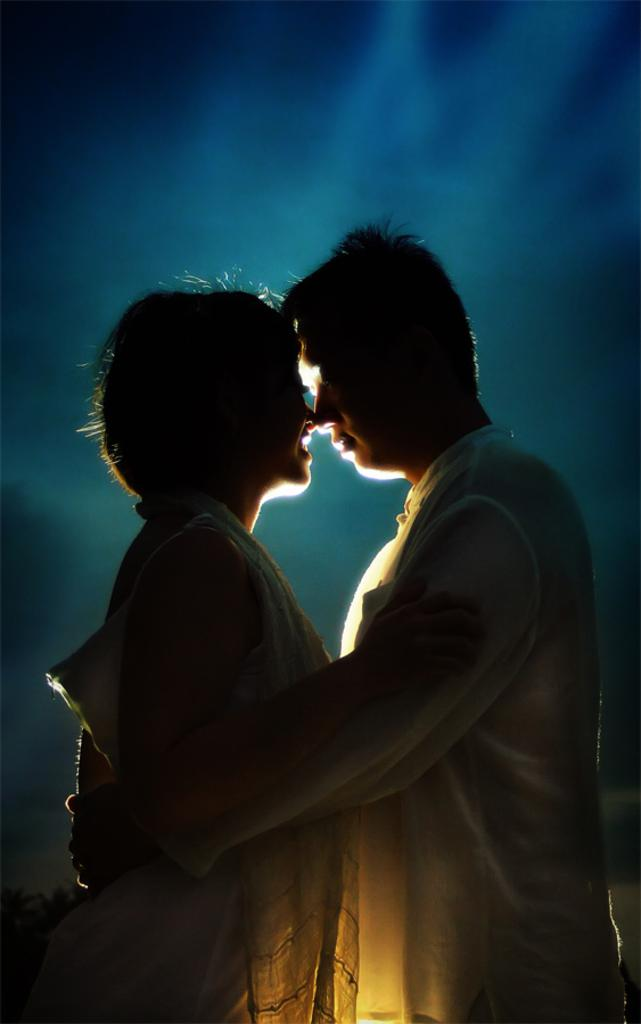How many people are present in the image? There are two people standing in the image. What is the man doing with the woman in the image? The man is holding the woman in the image. Can you describe the background of the image? The background of the image is blurry, and the sky is visible in the background. What type of hammer is the man using to act like a pig in the image? There is no hammer or pig present in the image, and the man is not acting like a pig. 